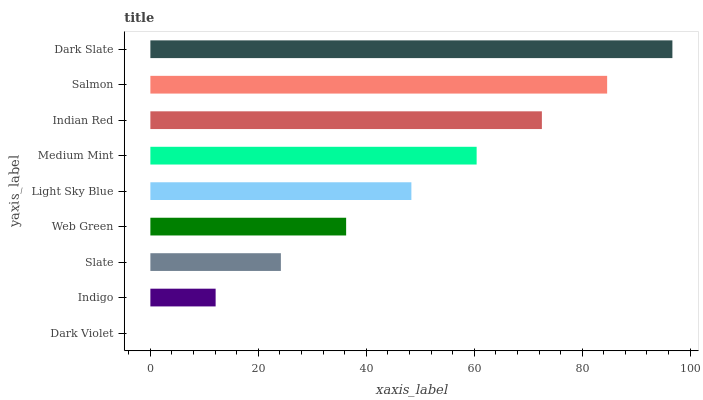Is Dark Violet the minimum?
Answer yes or no. Yes. Is Dark Slate the maximum?
Answer yes or no. Yes. Is Indigo the minimum?
Answer yes or no. No. Is Indigo the maximum?
Answer yes or no. No. Is Indigo greater than Dark Violet?
Answer yes or no. Yes. Is Dark Violet less than Indigo?
Answer yes or no. Yes. Is Dark Violet greater than Indigo?
Answer yes or no. No. Is Indigo less than Dark Violet?
Answer yes or no. No. Is Light Sky Blue the high median?
Answer yes or no. Yes. Is Light Sky Blue the low median?
Answer yes or no. Yes. Is Web Green the high median?
Answer yes or no. No. Is Dark Violet the low median?
Answer yes or no. No. 